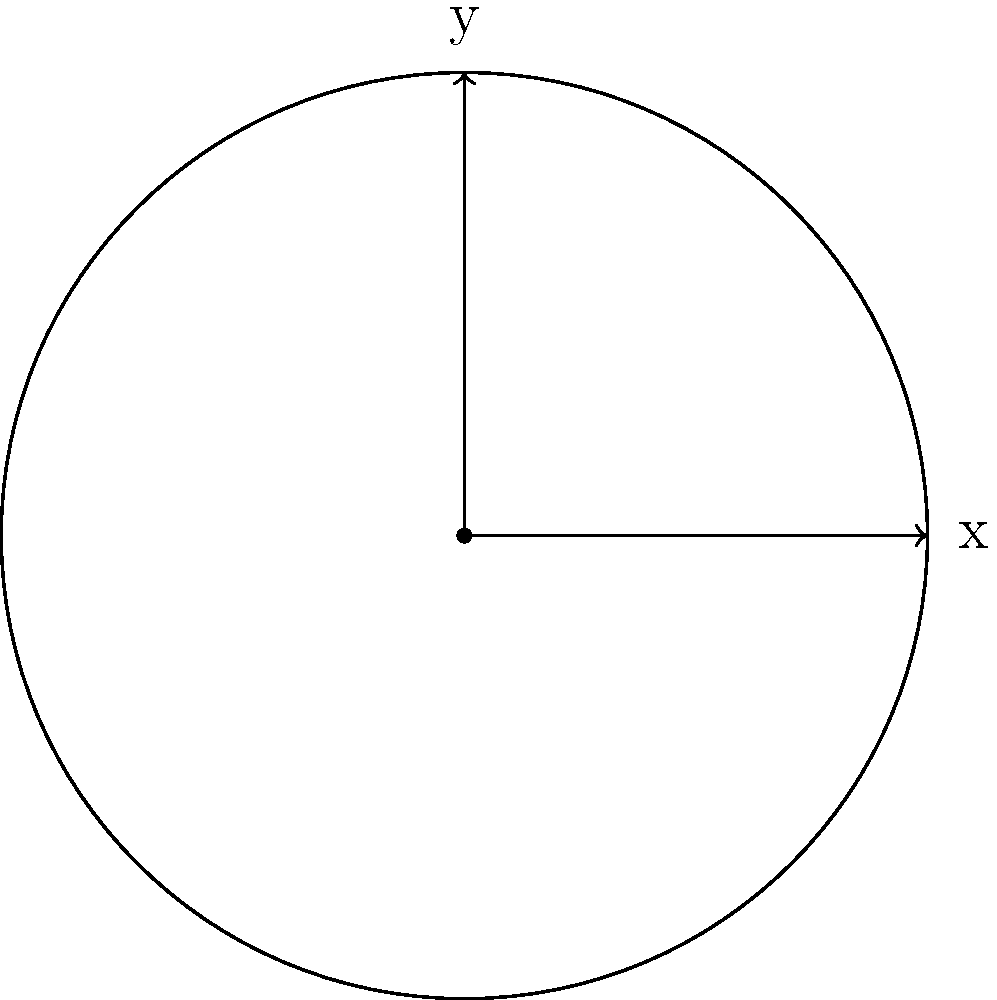As a sales representative for advanced sound equipment, you're explaining the symmetry properties of a circular microphone diaphragm to a harmonica player. The diaphragm can be modeled as a perfect circle in a 2D plane. What is the order of the symmetry group for this circular diaphragm, considering both rotational and reflectional symmetries? To determine the order of the symmetry group for a circular microphone diaphragm, we need to consider both rotational and reflectional symmetries:

1. Rotational symmetry:
   - A circle has infinite rotational symmetry, meaning it can be rotated by any angle around its center and remain unchanged.
   - This contributes infinitely many elements to the symmetry group.

2. Reflectional symmetry:
   - A circle has an infinite number of lines of reflection passing through its center.
   - Each of these lines of reflection is an axis of symmetry.
   - This contributes infinitely many elements to the symmetry group.

3. Identity transformation:
   - The identity transformation (no change) is also an element of the symmetry group.

4. Symmetry group:
   - The symmetry group of a circle is known as O(2), the orthogonal group in two dimensions.
   - It includes all rotations and reflections that preserve the circle.

5. Order of the symmetry group:
   - Due to the infinite number of rotations and reflections, the order of the symmetry group O(2) is infinite.

Therefore, the order of the symmetry group for the circular microphone diaphragm is infinite.
Answer: Infinite 